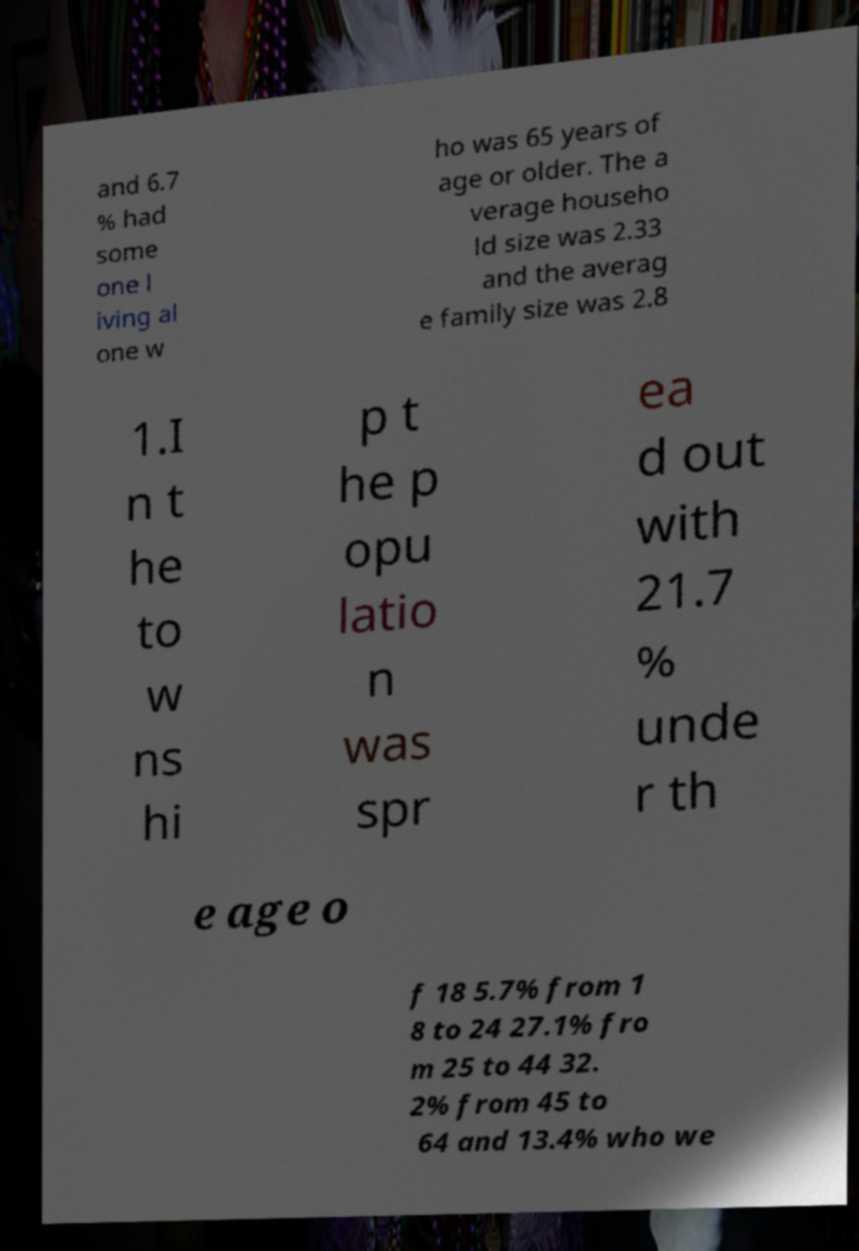What messages or text are displayed in this image? I need them in a readable, typed format. and 6.7 % had some one l iving al one w ho was 65 years of age or older. The a verage househo ld size was 2.33 and the averag e family size was 2.8 1.I n t he to w ns hi p t he p opu latio n was spr ea d out with 21.7 % unde r th e age o f 18 5.7% from 1 8 to 24 27.1% fro m 25 to 44 32. 2% from 45 to 64 and 13.4% who we 